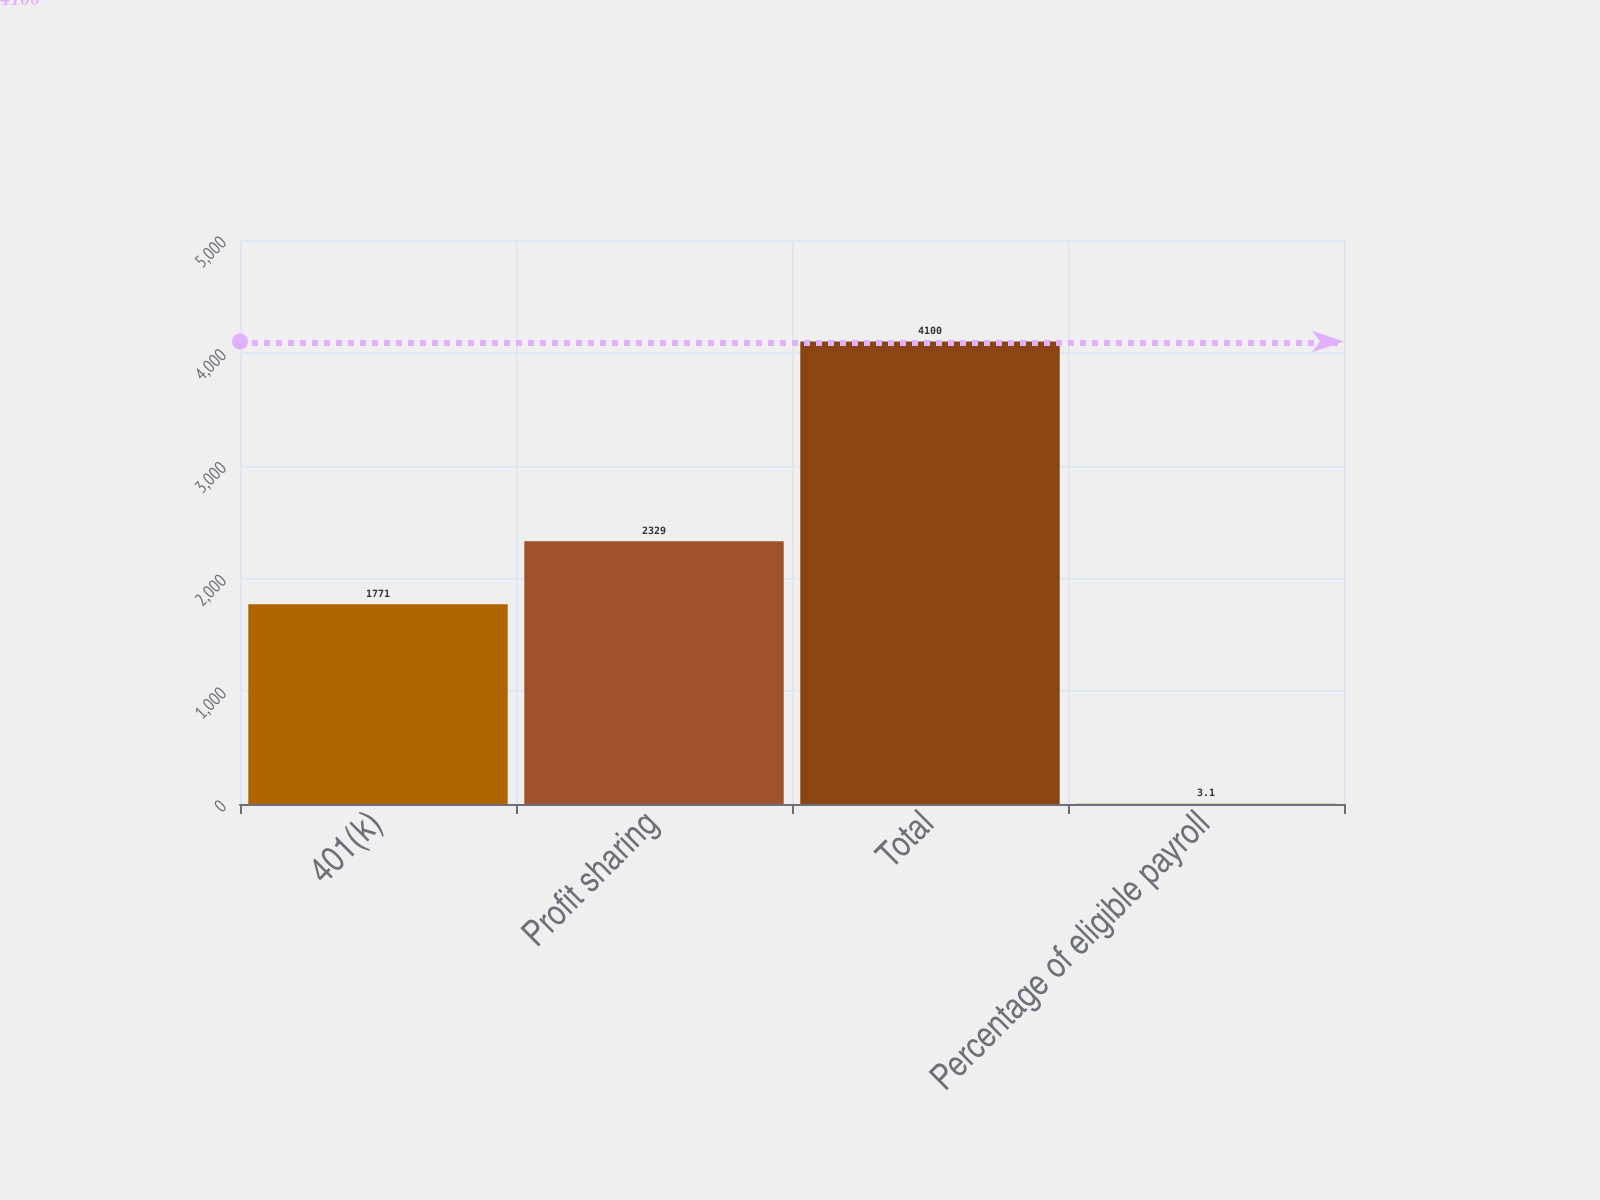Convert chart. <chart><loc_0><loc_0><loc_500><loc_500><bar_chart><fcel>401(k)<fcel>Profit sharing<fcel>Total<fcel>Percentage of eligible payroll<nl><fcel>1771<fcel>2329<fcel>4100<fcel>3.1<nl></chart> 